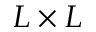<formula> <loc_0><loc_0><loc_500><loc_500>L \times L</formula> 